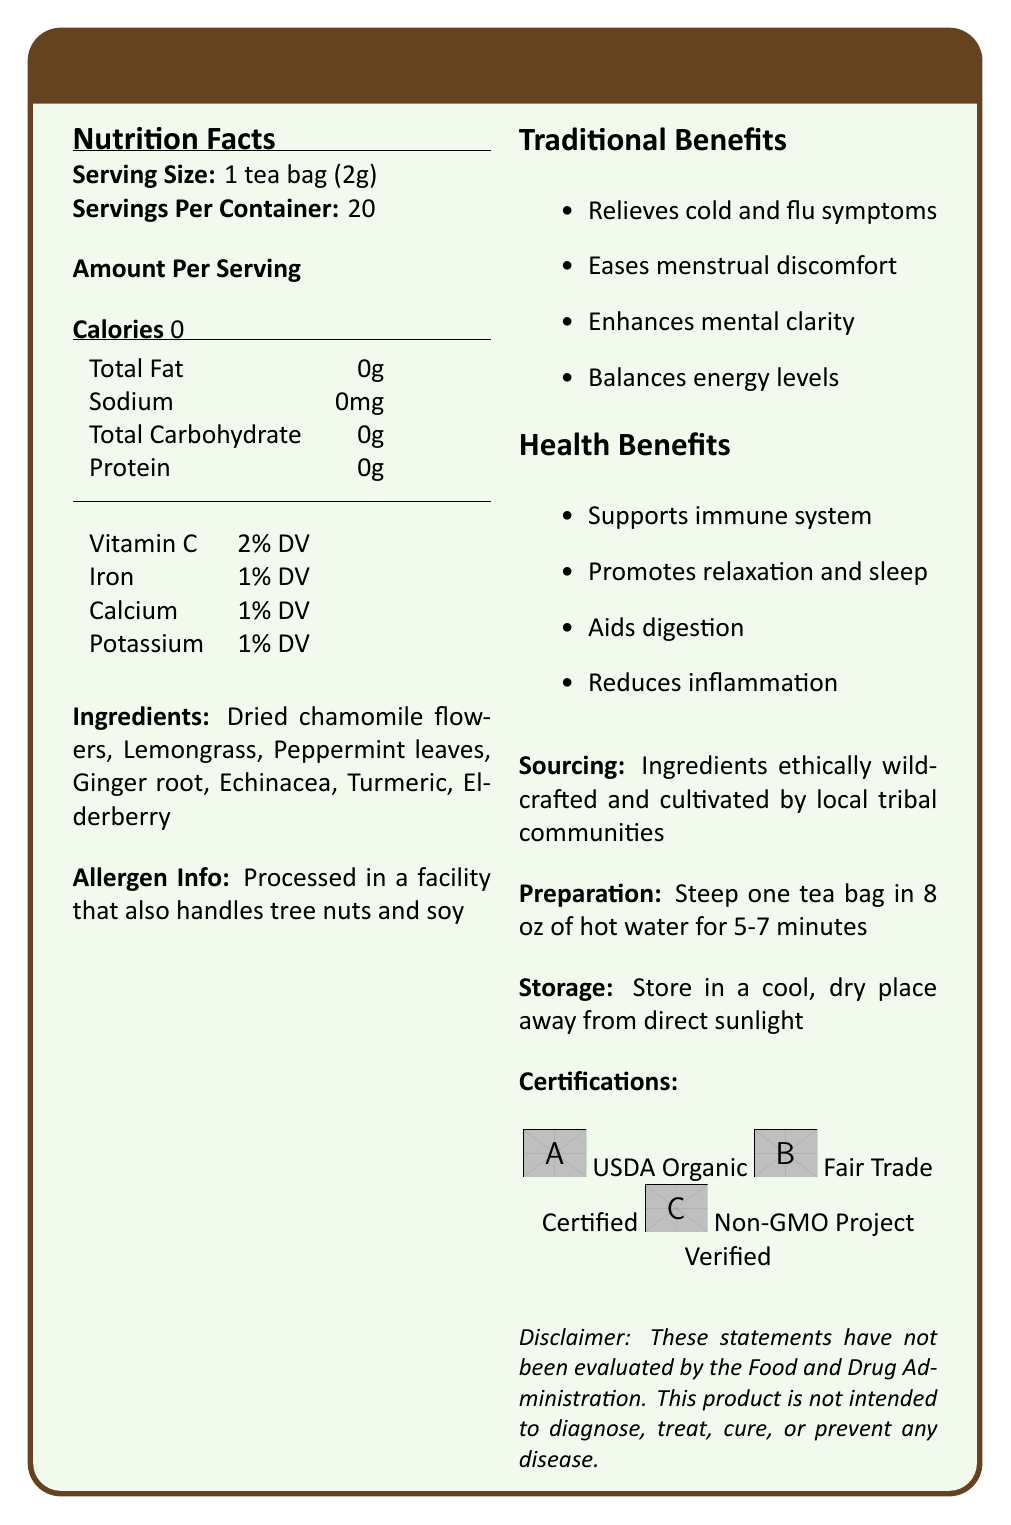what is the serving size for Sacred Harmony Herbal Tea Blend? The document lists the serving size as "1 tea bag (2g)".
Answer: 1 tea bag (2g) how many servings are there per container? The document specifies that there are 20 servings per container.
Answer: 20 how many calories are in one serving of this herbal tea blend? The document states that each serving contains 0 calories.
Answer: 0 which micronutrient is present in the highest daily value percentage in one serving? The document indicates that Vitamin C is present at 2% of the daily value.
Answer: Vitamin C list the ingredients used in Sacred Harmony Herbal Tea Blend. The document lists these ingredients in the ingredients section.
Answer: Dried chamomile flowers, Lemongrass, Peppermint leaves, Ginger root, Echinacea, Turmeric, Elderberry where are the ingredients for the tea blend sourced from? The document mentions that the ingredients are ethically wildcrafted and cultivated by local tribal communities.
Answer: Local tribal communities what is the sodium content in one serving of this tea blend? The sodium content in one serving is listed as 0mg in the document.
Answer: 0mg what are the health benefits of this herbal tea blend? These benefits are listed in the "Health Benefits" section of the document.
Answer: Supports immune system, Promotes relaxation and sleep, Aids digestion, Reduces inflammation which of the following is not an ingredient in the tea blend? A. Lemongrass B. Elderberry C. Lavender D. Echinacea Lavender is not listed as an ingredient in the document; the other three are.
Answer: C. Lavender what certifications does Sacred Harmony Herbal Tea Blend have? The document lists these certifications in the "Certifications" section.
Answer: USDA Organic, Fair Trade Certified, Non-GMO Project Verified is this product processed in a facility that handles other allergens? The document states that it is processed in a facility that also handles tree nuts and soy.
Answer: Yes what traditional uses does this tea blend have? The document lists these as traditional uses.
Answer: Relieves cold and flu symptoms, Eases menstrual discomfort, Enhances mental clarity, Balances energy levels which certification mark indicates the product is non-genetically modified? A. USDA Organic B. Fair Trade Certified C. Non-GMO Project Verified The Non-GMO Project Verified mark indicates that the product is non-genetically modified.
Answer: C. Non-GMO Project Verified how should you prepare a serving of this tea? The preparation instructions are specified in the document.
Answer: Steep one tea bag in 8 oz of hot water for 5-7 minutes does the tea blend contain protein? The document lists the protein content as 0g.
Answer: No summarize the main idea of the document. The document comprehensively details the nutritional aspects and benefits of the herbal tea blend, along with information on sourcing, usage, and certifications.
Answer: The document provides the nutritional information, health benefits, traditional uses, sourcing details, preparation and storage instructions, and certifications for Sacred Harmony Herbal Tea Blend, emphasizing its natural ingredients and traditional healing properties. are any artificial ingredients listed in the tea blend? The document lists only natural ingredients such as dried chamomile flowers, lemongrass, peppermint leaves, and others; no artificial ingredients are mentioned.
Answer: No what is the primary benefit of echinacea in the tea blend? The document does not specify the exact benefit of echinacea alone; it only lists general health benefits of the blend.
Answer: Cannot be determined how should Sacred Harmony Herbal Tea Blend be stored? The storage instructions are provided in the document.
Answer: Store in a cool, dry place away from direct sunlight 